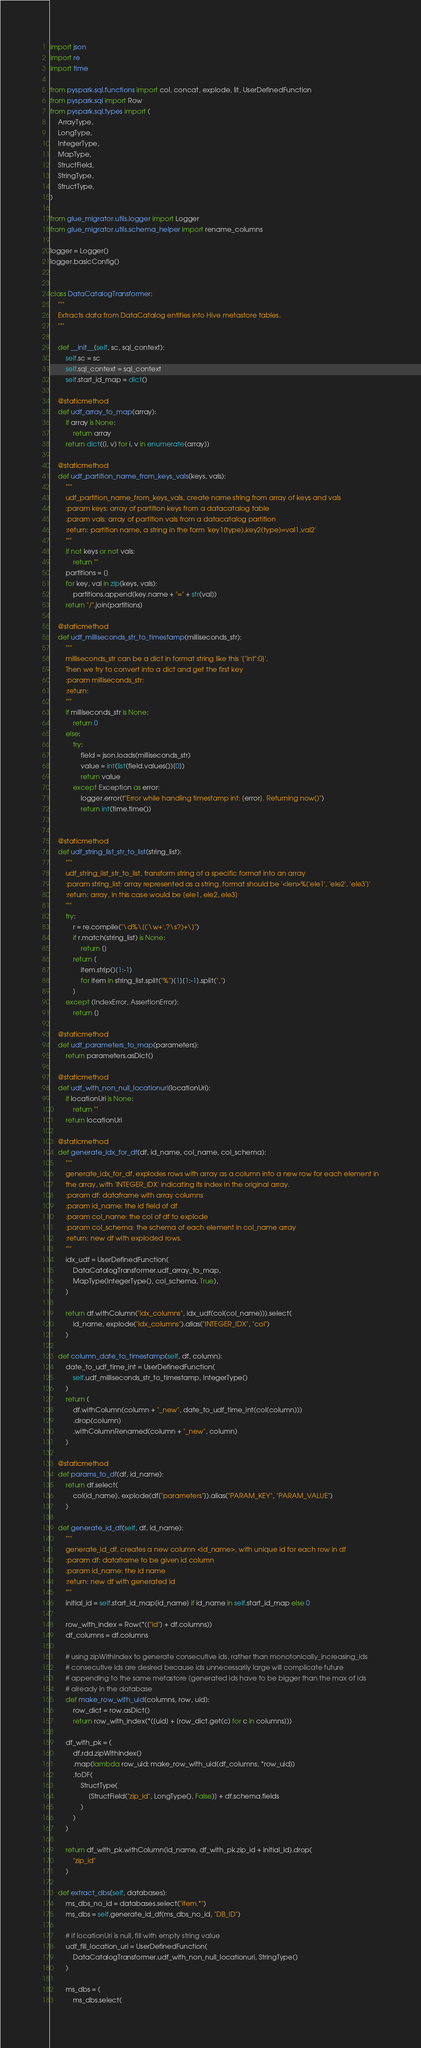<code> <loc_0><loc_0><loc_500><loc_500><_Python_>import json
import re
import time

from pyspark.sql.functions import col, concat, explode, lit, UserDefinedFunction
from pyspark.sql import Row
from pyspark.sql.types import (
    ArrayType,
    LongType,
    IntegerType,
    MapType,
    StructField,
    StringType,
    StructType,
)

from glue_migrator.utils.logger import Logger
from glue_migrator.utils.schema_helper import rename_columns

logger = Logger()
logger.basicConfig()


class DataCatalogTransformer:
    """
    Extracts data from DataCatalog entities into Hive metastore tables.
    """

    def __init__(self, sc, sql_context):
        self.sc = sc
        self.sql_context = sql_context
        self.start_id_map = dict()

    @staticmethod
    def udf_array_to_map(array):
        if array is None:
            return array
        return dict((i, v) for i, v in enumerate(array))

    @staticmethod
    def udf_partition_name_from_keys_vals(keys, vals):
        """
        udf_partition_name_from_keys_vals, create name string from array of keys and vals
        :param keys: array of partition keys from a datacatalog table
        :param vals: array of partition vals from a datacatalog partition
        :return: partition name, a string in the form 'key1(type),key2(type)=val1,val2'
        """
        if not keys or not vals:
            return ""
        partitions = []
        for key, val in zip(keys, vals):
            partitions.append(key.name + "=" + str(val))
        return "/".join(partitions)

    @staticmethod
    def udf_milliseconds_str_to_timestamp(milliseconds_str):
        """
        milliseconds_str can be a dict in format string like this '{"int":0}'.
        Then we try to convert into a dict and get the first key
        :param milliseconds_str:
        :return:
        """
        if milliseconds_str is None:
            return 0
        else:
            try:
                field = json.loads(milliseconds_str)
                value = int(list(field.values())[0])
                return value
            except Exception as error:
                logger.error(f"Error while handling timestamp int: {error}. Returning now()")
                return int(time.time())


    @staticmethod
    def udf_string_list_str_to_list(string_list):
        """
        udf_string_list_str_to_list, transform string of a specific format into an array
        :param string_list: array represented as a string, format should be '<len>%['ele1', 'ele2', 'ele3']'
        :return: array, in this case would be [ele1, ele2, ele3]
        """
        try:
            r = re.compile("\d%\[('\w+',?\s?)+\]")
            if r.match(string_list) is None:
                return []
            return [
                item.strip()[1:-1]
                for item in string_list.split("%")[1][1:-1].split(",")
            ]
        except (IndexError, AssertionError):
            return []

    @staticmethod
    def udf_parameters_to_map(parameters):
        return parameters.asDict()

    @staticmethod
    def udf_with_non_null_locationuri(locationUri):
        if locationUri is None:
            return ""
        return locationUri

    @staticmethod
    def generate_idx_for_df(df, id_name, col_name, col_schema):
        """
        generate_idx_for_df, explodes rows with array as a column into a new row for each element in
        the array, with 'INTEGER_IDX' indicating its index in the original array.
        :param df: dataframe with array columns
        :param id_name: the id field of df
        :param col_name: the col of df to explode
        :param col_schema: the schema of each element in col_name array
        :return: new df with exploded rows.
        """
        idx_udf = UserDefinedFunction(
            DataCatalogTransformer.udf_array_to_map,
            MapType(IntegerType(), col_schema, True),
        )

        return df.withColumn("idx_columns", idx_udf(col(col_name))).select(
            id_name, explode("idx_columns").alias("INTEGER_IDX", "col")
        )

    def column_date_to_timestamp(self, df, column):
        date_to_udf_time_int = UserDefinedFunction(
            self.udf_milliseconds_str_to_timestamp, IntegerType()
        )
        return (
            df.withColumn(column + "_new", date_to_udf_time_int(col(column)))
            .drop(column)
            .withColumnRenamed(column + "_new", column)
        )

    @staticmethod
    def params_to_df(df, id_name):
        return df.select(
            col(id_name), explode(df["parameters"]).alias("PARAM_KEY", "PARAM_VALUE")
        )

    def generate_id_df(self, df, id_name):
        """
        generate_id_df, creates a new column <id_name>, with unique id for each row in df
        :param df: dataframe to be given id column
        :param id_name: the id name
        :return: new df with generated id
        """
        initial_id = self.start_id_map[id_name] if id_name in self.start_id_map else 0

        row_with_index = Row(*(["id"] + df.columns))
        df_columns = df.columns

        # using zipWithIndex to generate consecutive ids, rather than monotonically_increasing_ids
        # consecutive ids are desired because ids unnecessarily large will complicate future
        # appending to the same metastore (generated ids have to be bigger than the max of ids
        # already in the database
        def make_row_with_uid(columns, row, uid):
            row_dict = row.asDict()
            return row_with_index(*([uid] + [row_dict.get(c) for c in columns]))

        df_with_pk = (
            df.rdd.zipWithIndex()
            .map(lambda row_uid: make_row_with_uid(df_columns, *row_uid))
            .toDF(
                StructType(
                    [StructField("zip_id", LongType(), False)] + df.schema.fields
                )
            )
        )

        return df_with_pk.withColumn(id_name, df_with_pk.zip_id + initial_id).drop(
            "zip_id"
        )

    def extract_dbs(self, databases):
        ms_dbs_no_id = databases.select("item.*")
        ms_dbs = self.generate_id_df(ms_dbs_no_id, "DB_ID")

        # if locationUri is null, fill with empty string value
        udf_fill_location_uri = UserDefinedFunction(
            DataCatalogTransformer.udf_with_non_null_locationuri, StringType()
        )

        ms_dbs = (
            ms_dbs.select(</code> 